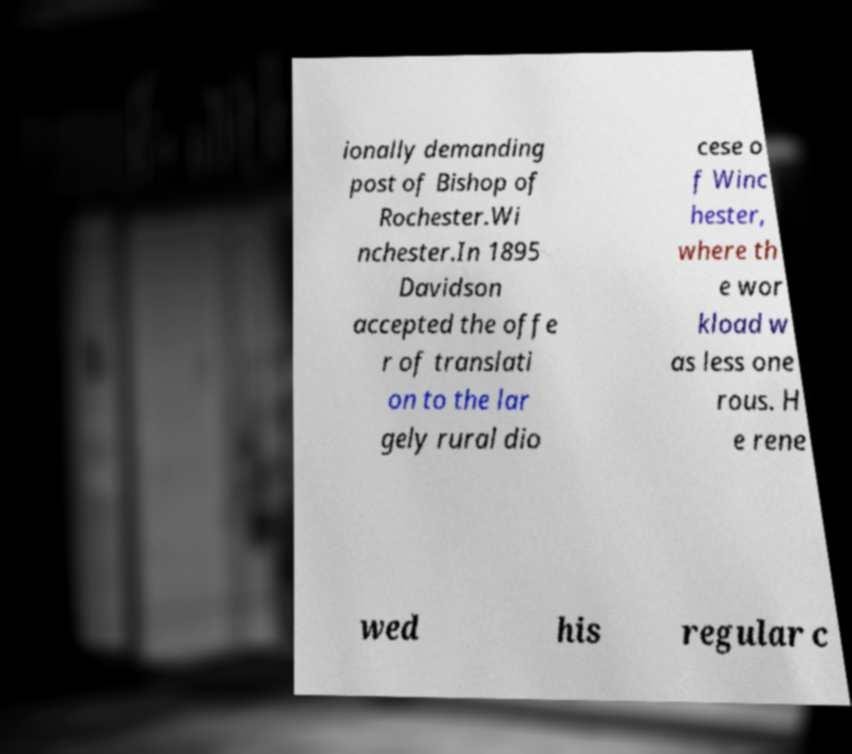Can you read and provide the text displayed in the image?This photo seems to have some interesting text. Can you extract and type it out for me? ionally demanding post of Bishop of Rochester.Wi nchester.In 1895 Davidson accepted the offe r of translati on to the lar gely rural dio cese o f Winc hester, where th e wor kload w as less one rous. H e rene wed his regular c 